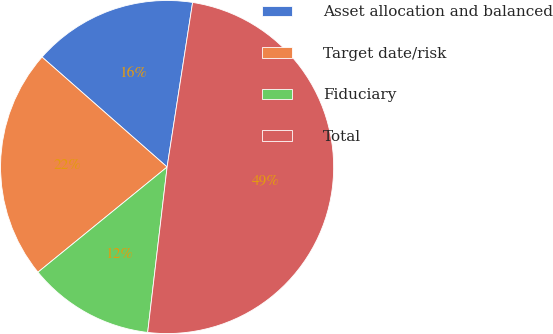Convert chart to OTSL. <chart><loc_0><loc_0><loc_500><loc_500><pie_chart><fcel>Asset allocation and balanced<fcel>Target date/risk<fcel>Fiduciary<fcel>Total<nl><fcel>15.97%<fcel>22.36%<fcel>12.26%<fcel>49.42%<nl></chart> 